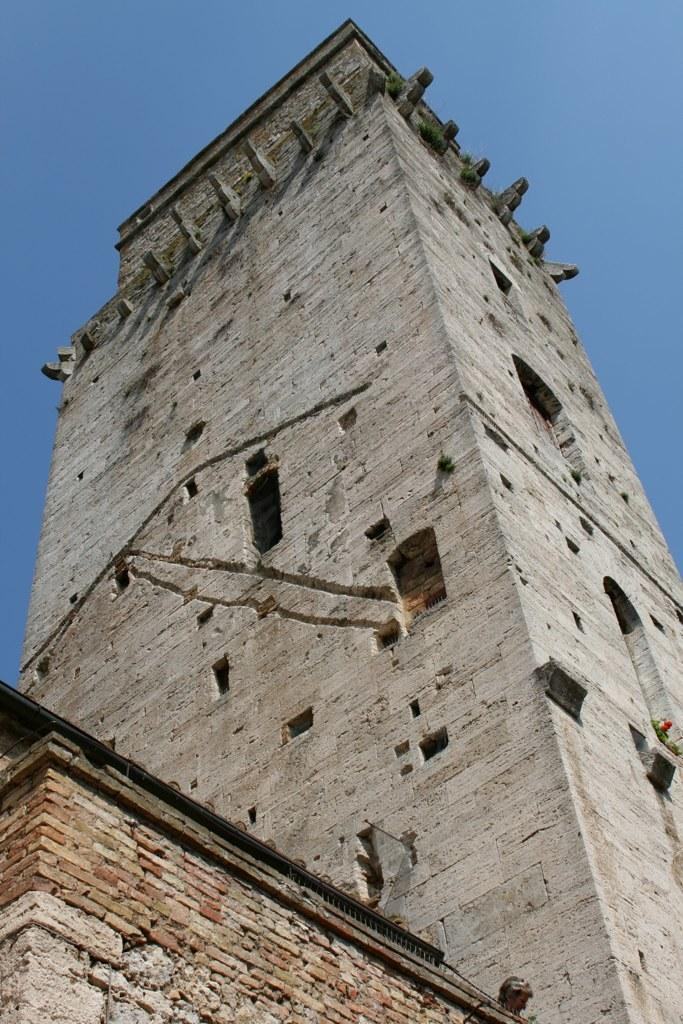What is the main subject of the image? The main subject of the image is a building. What specific features can be observed on the building? The building has windows. What can be seen in the background of the image? The sky is visible in the background of the image. How many errors can be seen in the building's design in the image? There is no indication of any errors in the building's design in the image. 